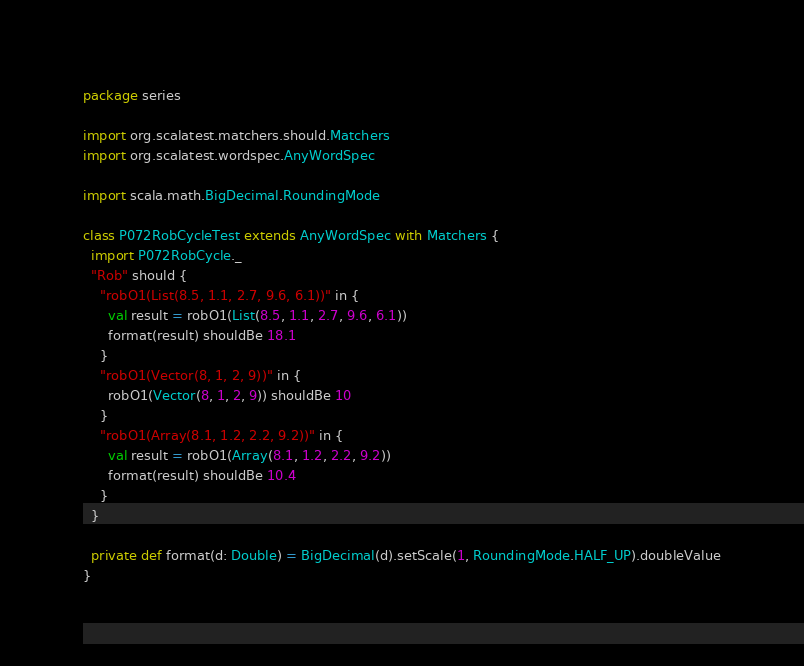Convert code to text. <code><loc_0><loc_0><loc_500><loc_500><_Scala_>package series

import org.scalatest.matchers.should.Matchers
import org.scalatest.wordspec.AnyWordSpec

import scala.math.BigDecimal.RoundingMode

class P072RobCycleTest extends AnyWordSpec with Matchers {
  import P072RobCycle._
  "Rob" should {
    "robO1(List(8.5, 1.1, 2.7, 9.6, 6.1))" in {
      val result = robO1(List(8.5, 1.1, 2.7, 9.6, 6.1))
      format(result) shouldBe 18.1
    }
    "robO1(Vector(8, 1, 2, 9))" in {
      robO1(Vector(8, 1, 2, 9)) shouldBe 10
    }
    "robO1(Array(8.1, 1.2, 2.2, 9.2))" in {
      val result = robO1(Array(8.1, 1.2, 2.2, 9.2))
      format(result) shouldBe 10.4
    }
  }

  private def format(d: Double) = BigDecimal(d).setScale(1, RoundingMode.HALF_UP).doubleValue
}
</code> 